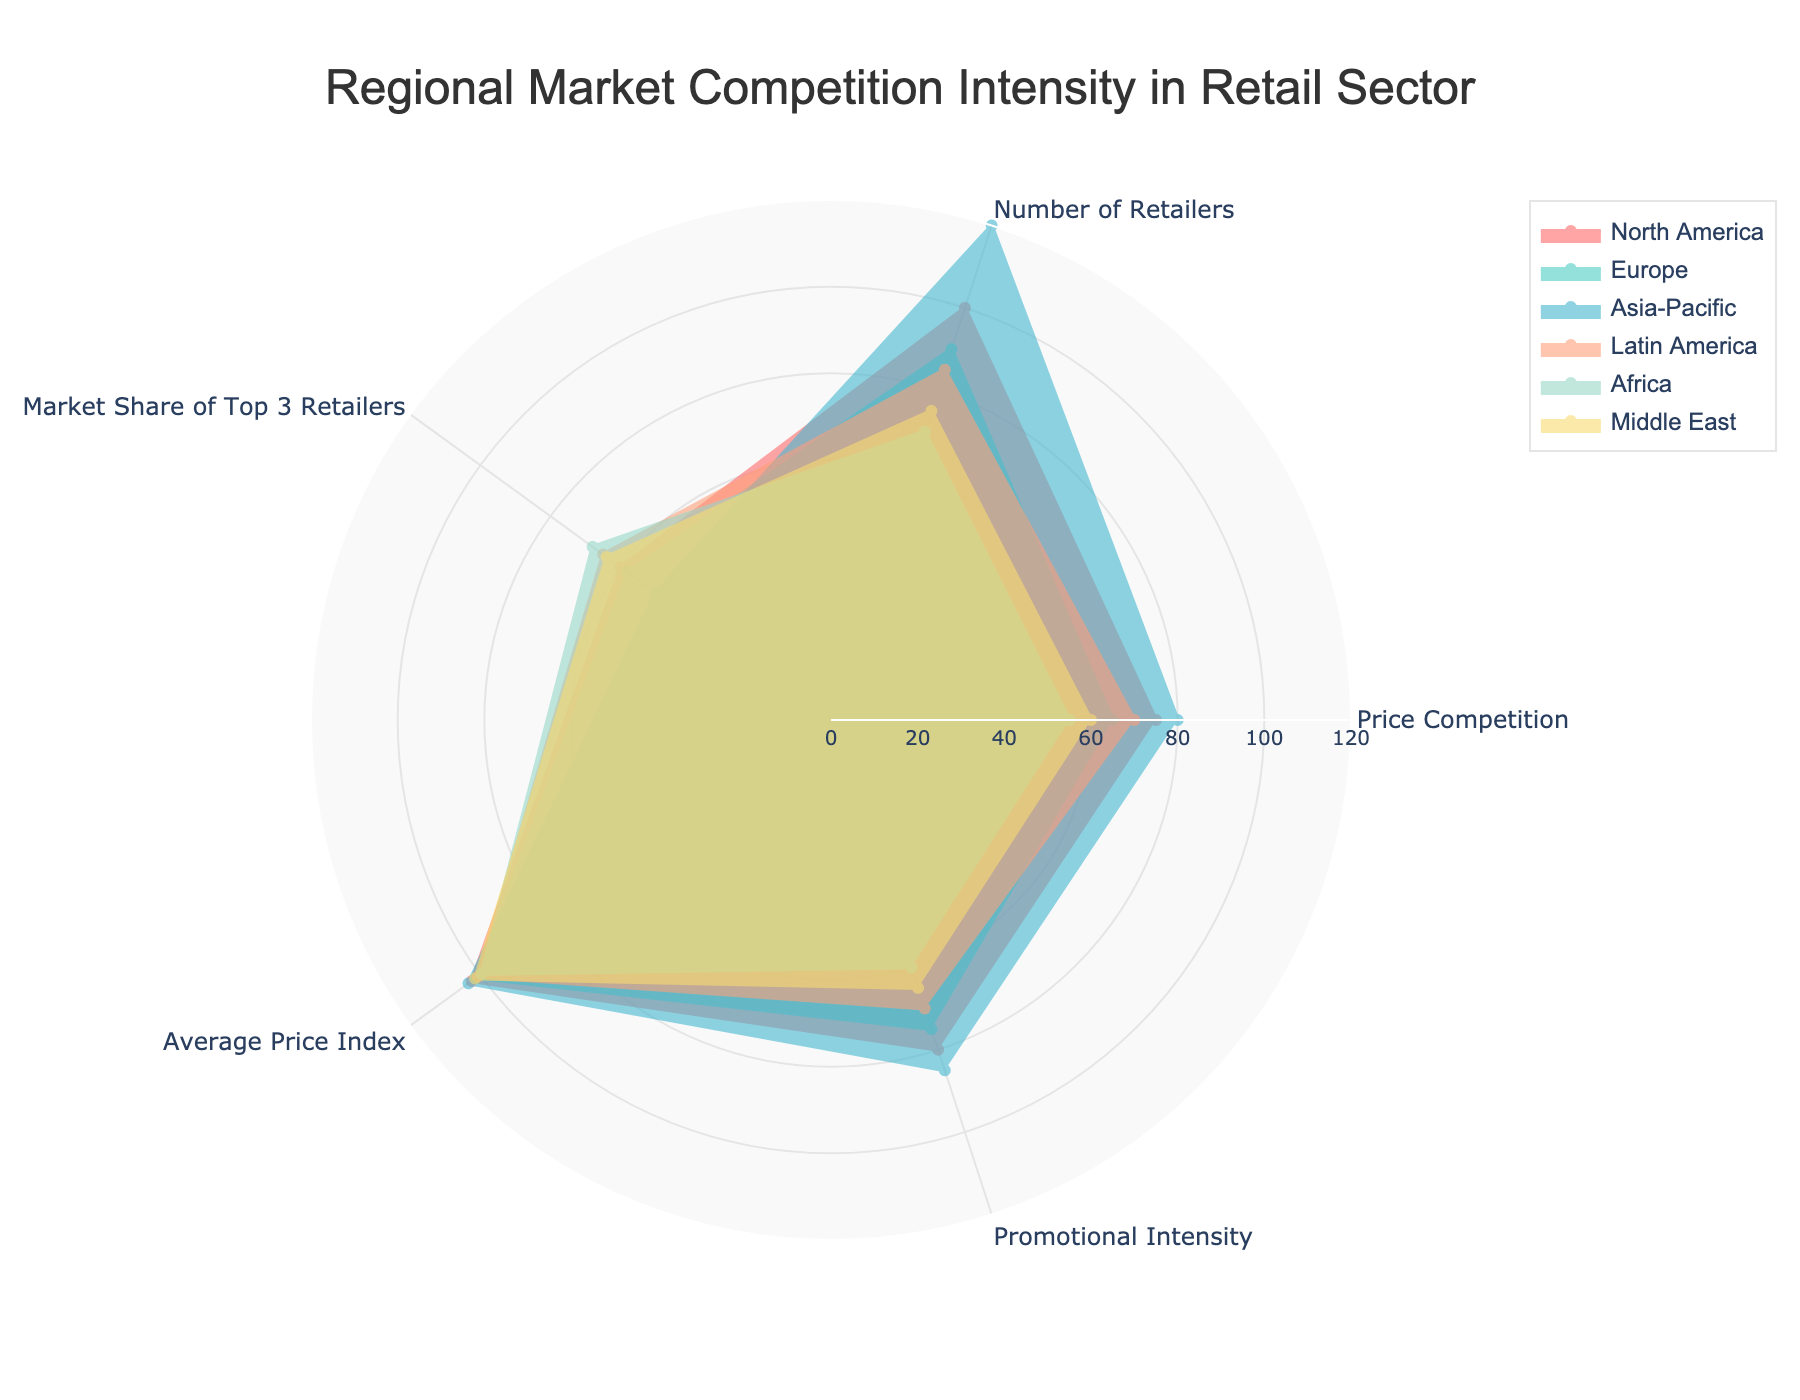What is the title of the figure? The title of the figure is displayed prominently at the top of the radar chart. It helps in understanding the context and focus of the visualization.
Answer: Regional Market Competition Intensity in Retail Sector How many regions are compared in this radar chart? By examining the legend or the individual data traces on the radar chart, you can count the unique regions presented.
Answer: Six Which region has the highest value for Price Competition? Look at the 'Price Competition' axis and identify which region's trace has the maximum value on this axis.
Answer: Asia-Pacific What is the average Promotional Intensity across all regions? Add up the Promotional Intensity values for all regions and divide by the number of regions. (80 + 75 + 85 + 70 + 60 + 65) / 6 = 72.5
Answer: 72.5 Which regions have the number of retailers greater than 90? Compare the 'Number of Retailers' values for each region and identify which ones exceed 90.
Answer: North America, Asia-Pacific Which region shows the least market share of the top 3 retailers? Look at the 'Market Share of Top 3 Retailers' axis and identify the region with the lowest value.
Answer: Asia-Pacific What is the combined Average Price Index of North America and Middle East? Add up the Average Price Index values for North America and Middle East. 102.5 + 101.5 = 204
Answer: 204 What is the difference in Market Share of Top 3 Retailers between Europe and Latin America? Subtract the Market Share of Top 3 Retailers value of Europe from that of Latin America. 65 - 58 = 7
Answer: 7 Which region has the most balanced competition in terms of Price Competition, Number of Retailers, and Promotional Intensity? Identify the region whose values for Price Competition, Number of Retailers, and Promotional Intensity are closest to each other, indicating balance.
Answer: North America Is there any region with a Promotional Intensity lower than 70 but has an Average Price Index above 100? Check the 'Promotional Intensity' and 'Average Price Index' values for each region to find if any region meets both conditions.
Answer: Middle East 